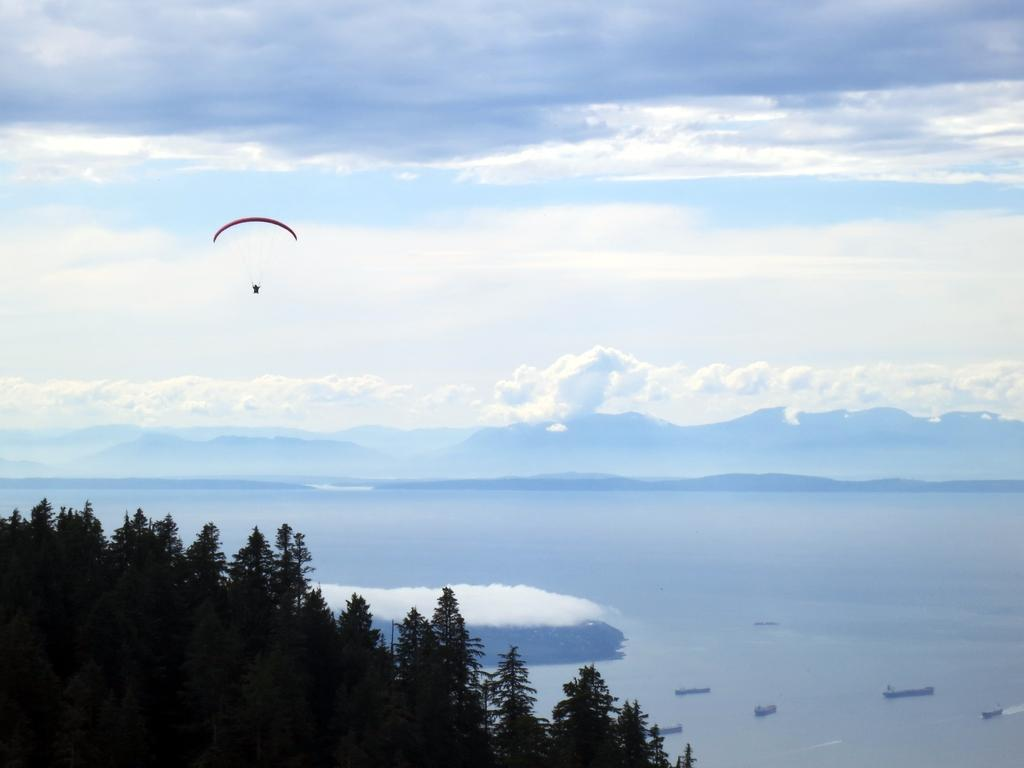What type of vegetation can be seen in the image? There are trees in the image. What is visible in the sky in the image? There are clouds in the sky. What is the object descending from the sky in the image? A parachute is visible in the image. What body of water is present in the image? There is water in the image. What type of vehicles are present in the water? There are boats in the water. Where is the laborer working in the image? There is no laborer present in the image. What type of environment is the seashore located in the image? There is no seashore present in the image. 